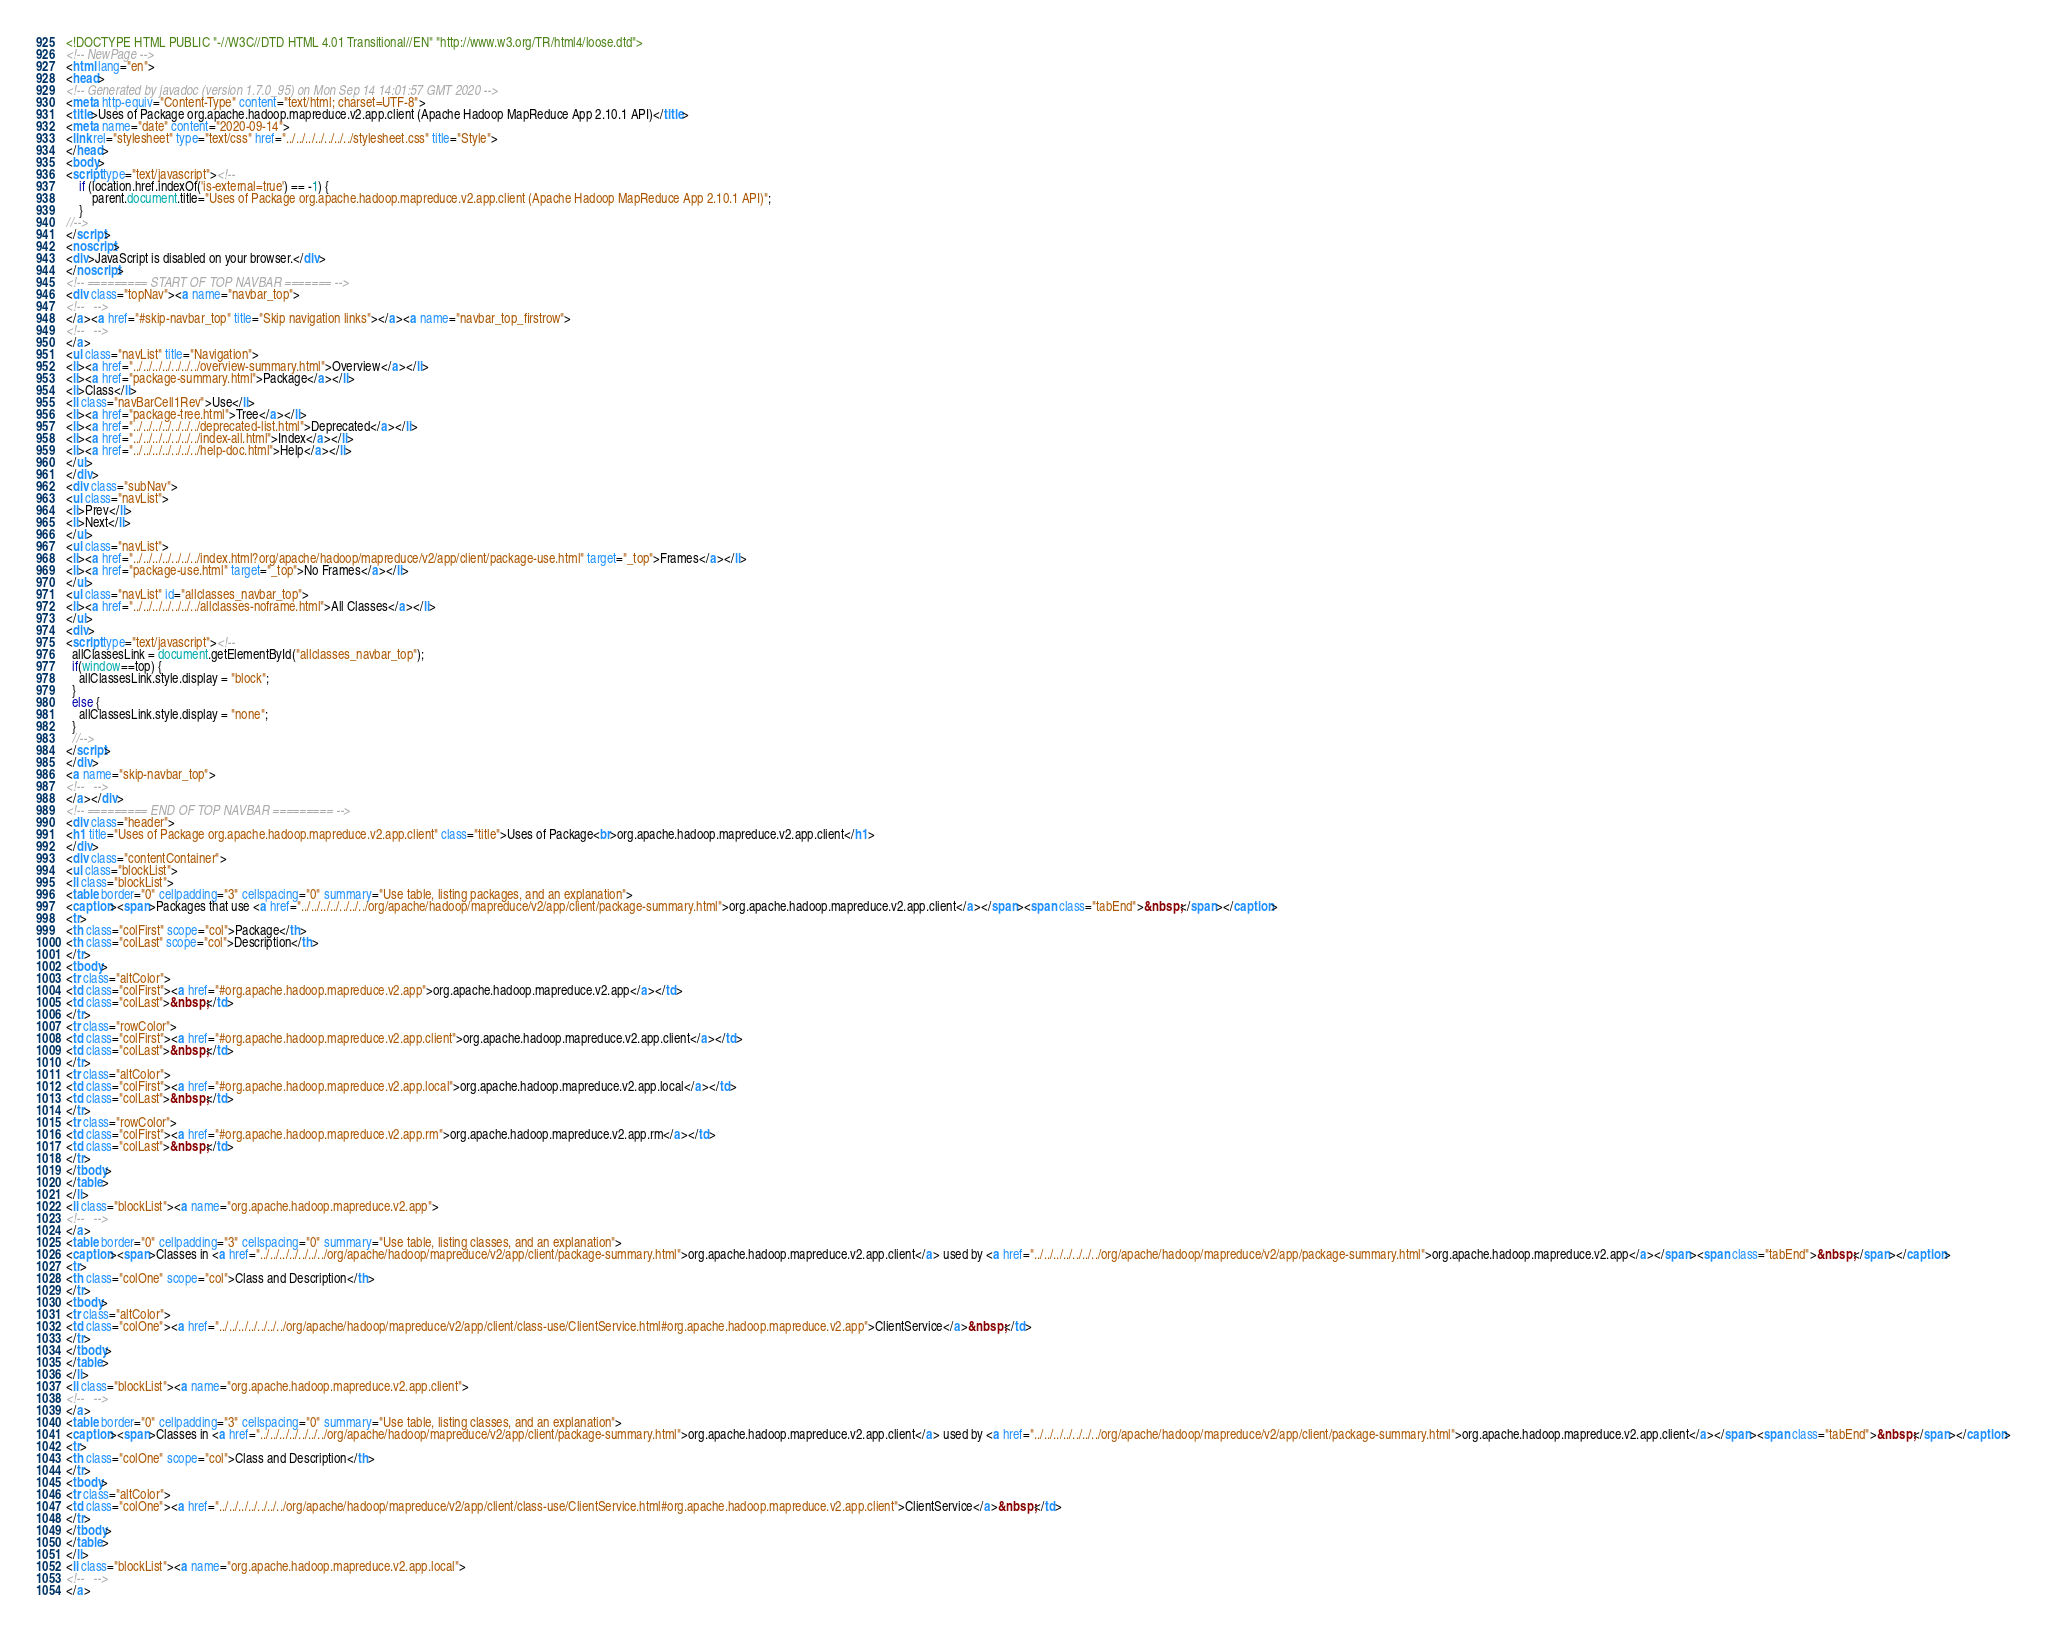Convert code to text. <code><loc_0><loc_0><loc_500><loc_500><_HTML_><!DOCTYPE HTML PUBLIC "-//W3C//DTD HTML 4.01 Transitional//EN" "http://www.w3.org/TR/html4/loose.dtd">
<!-- NewPage -->
<html lang="en">
<head>
<!-- Generated by javadoc (version 1.7.0_95) on Mon Sep 14 14:01:57 GMT 2020 -->
<meta http-equiv="Content-Type" content="text/html; charset=UTF-8">
<title>Uses of Package org.apache.hadoop.mapreduce.v2.app.client (Apache Hadoop MapReduce App 2.10.1 API)</title>
<meta name="date" content="2020-09-14">
<link rel="stylesheet" type="text/css" href="../../../../../../../stylesheet.css" title="Style">
</head>
<body>
<script type="text/javascript"><!--
    if (location.href.indexOf('is-external=true') == -1) {
        parent.document.title="Uses of Package org.apache.hadoop.mapreduce.v2.app.client (Apache Hadoop MapReduce App 2.10.1 API)";
    }
//-->
</script>
<noscript>
<div>JavaScript is disabled on your browser.</div>
</noscript>
<!-- ========= START OF TOP NAVBAR ======= -->
<div class="topNav"><a name="navbar_top">
<!--   -->
</a><a href="#skip-navbar_top" title="Skip navigation links"></a><a name="navbar_top_firstrow">
<!--   -->
</a>
<ul class="navList" title="Navigation">
<li><a href="../../../../../../../overview-summary.html">Overview</a></li>
<li><a href="package-summary.html">Package</a></li>
<li>Class</li>
<li class="navBarCell1Rev">Use</li>
<li><a href="package-tree.html">Tree</a></li>
<li><a href="../../../../../../../deprecated-list.html">Deprecated</a></li>
<li><a href="../../../../../../../index-all.html">Index</a></li>
<li><a href="../../../../../../../help-doc.html">Help</a></li>
</ul>
</div>
<div class="subNav">
<ul class="navList">
<li>Prev</li>
<li>Next</li>
</ul>
<ul class="navList">
<li><a href="../../../../../../../index.html?org/apache/hadoop/mapreduce/v2/app/client/package-use.html" target="_top">Frames</a></li>
<li><a href="package-use.html" target="_top">No Frames</a></li>
</ul>
<ul class="navList" id="allclasses_navbar_top">
<li><a href="../../../../../../../allclasses-noframe.html">All Classes</a></li>
</ul>
<div>
<script type="text/javascript"><!--
  allClassesLink = document.getElementById("allclasses_navbar_top");
  if(window==top) {
    allClassesLink.style.display = "block";
  }
  else {
    allClassesLink.style.display = "none";
  }
  //-->
</script>
</div>
<a name="skip-navbar_top">
<!--   -->
</a></div>
<!-- ========= END OF TOP NAVBAR ========= -->
<div class="header">
<h1 title="Uses of Package org.apache.hadoop.mapreduce.v2.app.client" class="title">Uses of Package<br>org.apache.hadoop.mapreduce.v2.app.client</h1>
</div>
<div class="contentContainer">
<ul class="blockList">
<li class="blockList">
<table border="0" cellpadding="3" cellspacing="0" summary="Use table, listing packages, and an explanation">
<caption><span>Packages that use <a href="../../../../../../../org/apache/hadoop/mapreduce/v2/app/client/package-summary.html">org.apache.hadoop.mapreduce.v2.app.client</a></span><span class="tabEnd">&nbsp;</span></caption>
<tr>
<th class="colFirst" scope="col">Package</th>
<th class="colLast" scope="col">Description</th>
</tr>
<tbody>
<tr class="altColor">
<td class="colFirst"><a href="#org.apache.hadoop.mapreduce.v2.app">org.apache.hadoop.mapreduce.v2.app</a></td>
<td class="colLast">&nbsp;</td>
</tr>
<tr class="rowColor">
<td class="colFirst"><a href="#org.apache.hadoop.mapreduce.v2.app.client">org.apache.hadoop.mapreduce.v2.app.client</a></td>
<td class="colLast">&nbsp;</td>
</tr>
<tr class="altColor">
<td class="colFirst"><a href="#org.apache.hadoop.mapreduce.v2.app.local">org.apache.hadoop.mapreduce.v2.app.local</a></td>
<td class="colLast">&nbsp;</td>
</tr>
<tr class="rowColor">
<td class="colFirst"><a href="#org.apache.hadoop.mapreduce.v2.app.rm">org.apache.hadoop.mapreduce.v2.app.rm</a></td>
<td class="colLast">&nbsp;</td>
</tr>
</tbody>
</table>
</li>
<li class="blockList"><a name="org.apache.hadoop.mapreduce.v2.app">
<!--   -->
</a>
<table border="0" cellpadding="3" cellspacing="0" summary="Use table, listing classes, and an explanation">
<caption><span>Classes in <a href="../../../../../../../org/apache/hadoop/mapreduce/v2/app/client/package-summary.html">org.apache.hadoop.mapreduce.v2.app.client</a> used by <a href="../../../../../../../org/apache/hadoop/mapreduce/v2/app/package-summary.html">org.apache.hadoop.mapreduce.v2.app</a></span><span class="tabEnd">&nbsp;</span></caption>
<tr>
<th class="colOne" scope="col">Class and Description</th>
</tr>
<tbody>
<tr class="altColor">
<td class="colOne"><a href="../../../../../../../org/apache/hadoop/mapreduce/v2/app/client/class-use/ClientService.html#org.apache.hadoop.mapreduce.v2.app">ClientService</a>&nbsp;</td>
</tr>
</tbody>
</table>
</li>
<li class="blockList"><a name="org.apache.hadoop.mapreduce.v2.app.client">
<!--   -->
</a>
<table border="0" cellpadding="3" cellspacing="0" summary="Use table, listing classes, and an explanation">
<caption><span>Classes in <a href="../../../../../../../org/apache/hadoop/mapreduce/v2/app/client/package-summary.html">org.apache.hadoop.mapreduce.v2.app.client</a> used by <a href="../../../../../../../org/apache/hadoop/mapreduce/v2/app/client/package-summary.html">org.apache.hadoop.mapreduce.v2.app.client</a></span><span class="tabEnd">&nbsp;</span></caption>
<tr>
<th class="colOne" scope="col">Class and Description</th>
</tr>
<tbody>
<tr class="altColor">
<td class="colOne"><a href="../../../../../../../org/apache/hadoop/mapreduce/v2/app/client/class-use/ClientService.html#org.apache.hadoop.mapreduce.v2.app.client">ClientService</a>&nbsp;</td>
</tr>
</tbody>
</table>
</li>
<li class="blockList"><a name="org.apache.hadoop.mapreduce.v2.app.local">
<!--   -->
</a></code> 